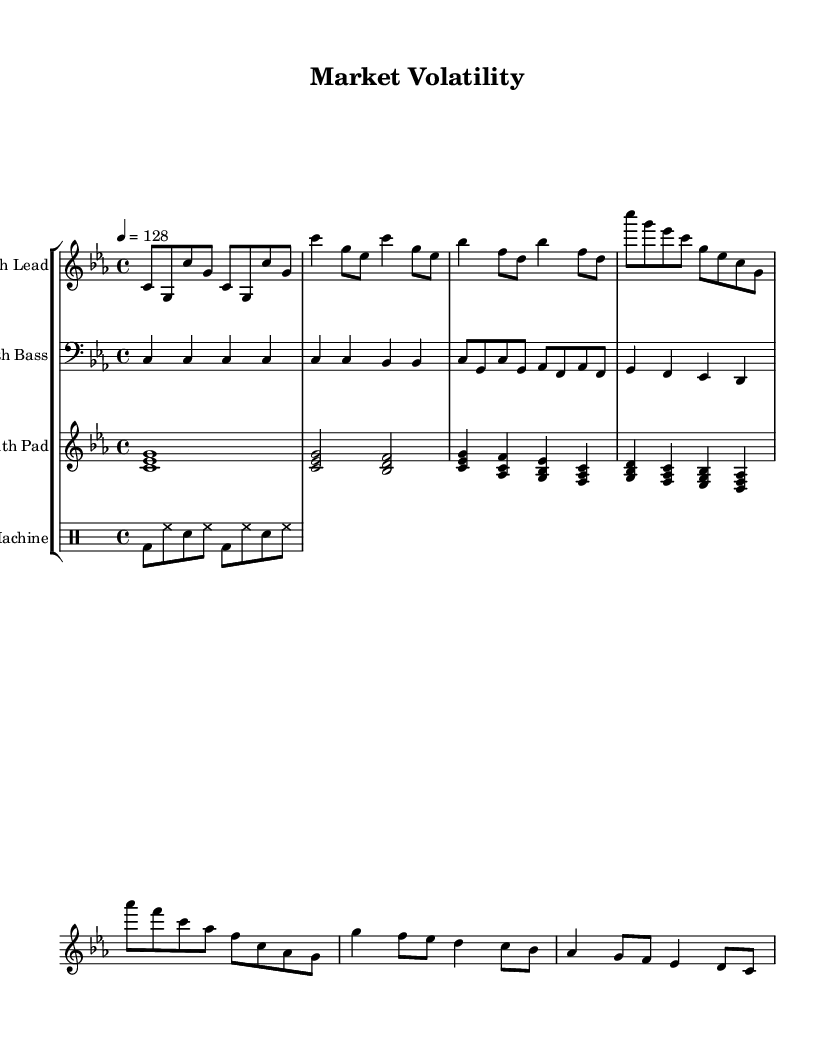What is the key signature of this music? The key signature shown at the beginning of the staff is C minor, which typically indicates a flat key with three flats (B flat, E flat, and A flat). In this case, the absence of any sharp or flat markings during the performance implies it's in C minor.
Answer: C minor What is the time signature of this music? The time signature, located near the beginning of the score, is represented by "4/4", which indicates there are four beats in each measure and the quarter note receives one beat. This is a common time signature for many genres, including electronic music.
Answer: 4/4 What is the tempo of this music? The tempo marking at the beginning is indicated by "4 = 128", which specifies that the quarter note should be played at a speed of 128 beats per minute, a common tempo for electronic dance music.
Answer: 128 How many different instrument parts are there in this score? By counting the instrument groups in the score, there are a total of four parts: Synth Lead, Synth Bass, Synth Pad, and Drum Machine. This indicates a layered and rich texture typical in electronic music.
Answer: Four Which section of the music consists of the synth bass playing repeated notes? The section labeled "Intro" shows the synth bass playing the note C four times in a single measure, indicating a repetitive and stable foundation which is characteristic in electronic music to create a consistent groove.
Answer: Intro What are the notes used in the chorus section for the synth lead? In the chorus section, the notes played by the synth lead are C, G, E flat, C, G, E flat, C, G, A flat, F, C, A flat, F, C, A flat, G. This melodic pattern contributes to the uplift and contrast often found in electronic tracks.
Answer: C, G, E flat, C, G, E flat, C, G, A flat, F, C, A flat, F, C, A flat, G What rhythmic pattern is repeated for the drum machine? The drum machine plays a rhythmic pattern consisting of bass drum and hi-hat with snare hits interspersed, which creates a driving beat typical in electronic music. The pattern is consistent across the pattern shown in the score.
Answer: Bass drum, hi-hat, snare 